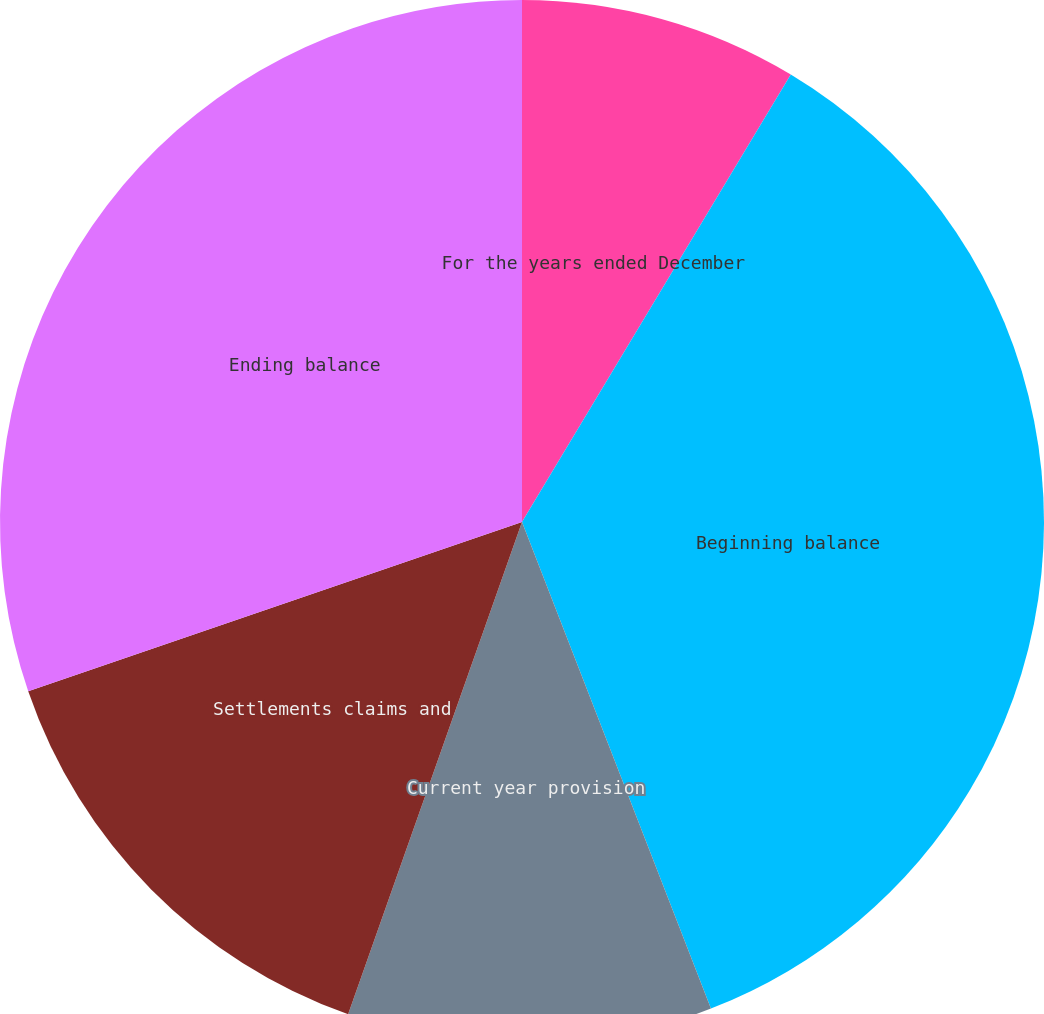Convert chart. <chart><loc_0><loc_0><loc_500><loc_500><pie_chart><fcel>For the years ended December<fcel>Beginning balance<fcel>Current year provision<fcel>Settlements claims and<fcel>Ending balance<nl><fcel>8.61%<fcel>35.5%<fcel>11.3%<fcel>14.34%<fcel>30.26%<nl></chart> 